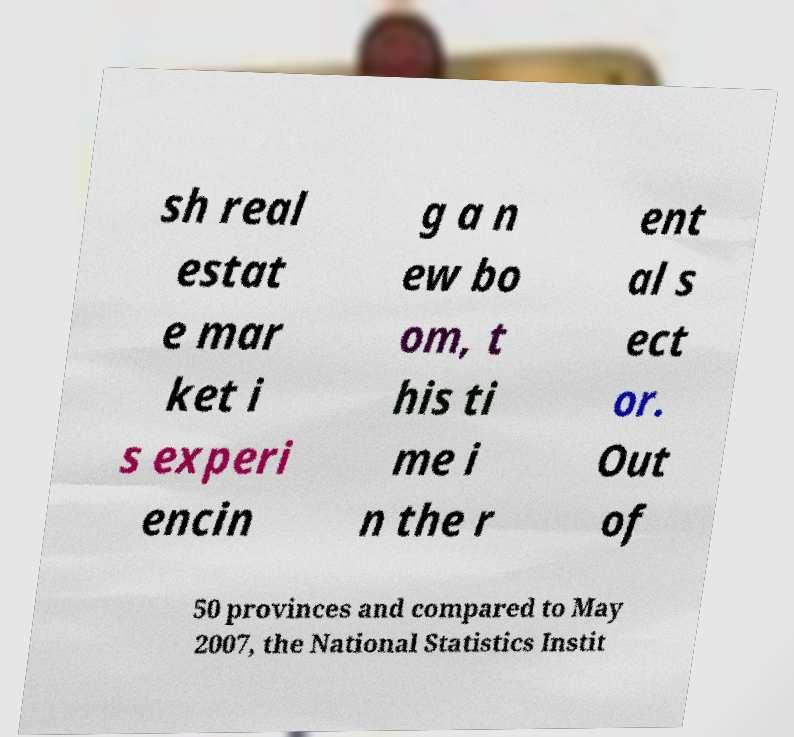Please identify and transcribe the text found in this image. sh real estat e mar ket i s experi encin g a n ew bo om, t his ti me i n the r ent al s ect or. Out of 50 provinces and compared to May 2007, the National Statistics Instit 